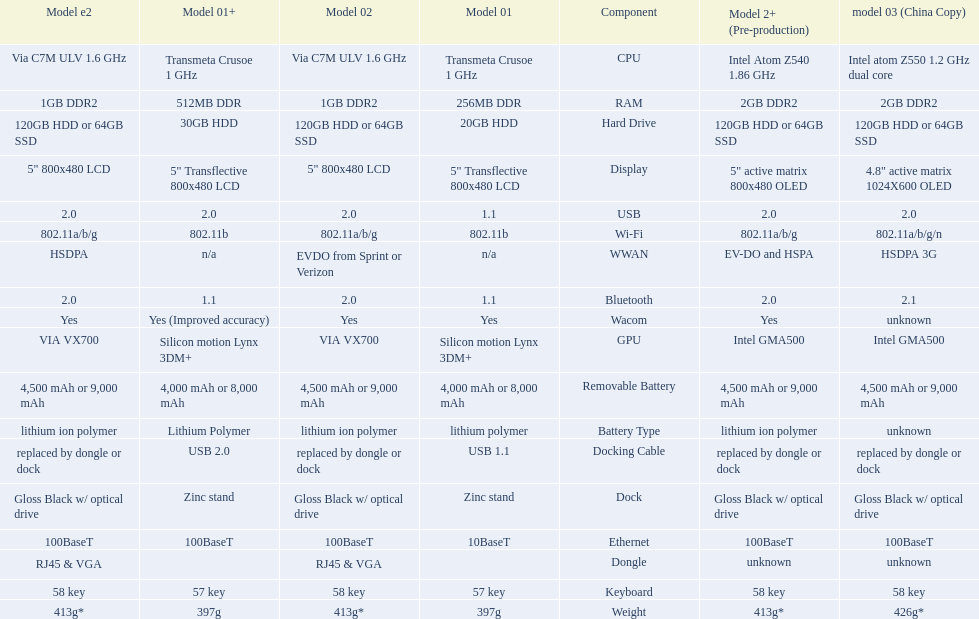Parse the full table. {'header': ['Model e2', 'Model 01+', 'Model 02', 'Model 01', 'Component', 'Model 2+ (Pre-production)', 'model 03 (China Copy)'], 'rows': [['Via C7M ULV 1.6\xa0GHz', 'Transmeta Crusoe 1\xa0GHz', 'Via C7M ULV 1.6\xa0GHz', 'Transmeta Crusoe 1\xa0GHz', 'CPU', 'Intel Atom Z540 1.86\xa0GHz', 'Intel atom Z550 1.2\xa0GHz dual core'], ['1GB DDR2', '512MB DDR', '1GB DDR2', '256MB DDR', 'RAM', '2GB DDR2', '2GB DDR2'], ['120GB HDD or 64GB SSD', '30GB HDD', '120GB HDD or 64GB SSD', '20GB HDD', 'Hard Drive', '120GB HDD or 64GB SSD', '120GB HDD or 64GB SSD'], ['5" 800x480 LCD', '5" Transflective 800x480 LCD', '5" 800x480 LCD', '5" Transflective 800x480 LCD', 'Display', '5" active matrix 800x480 OLED', '4.8" active matrix 1024X600 OLED'], ['2.0', '2.0', '2.0', '1.1', 'USB', '2.0', '2.0'], ['802.11a/b/g', '802.11b', '802.11a/b/g', '802.11b', 'Wi-Fi', '802.11a/b/g', '802.11a/b/g/n'], ['HSDPA', 'n/a', 'EVDO from Sprint or Verizon', 'n/a', 'WWAN', 'EV-DO and HSPA', 'HSDPA 3G'], ['2.0', '1.1', '2.0', '1.1', 'Bluetooth', '2.0', '2.1'], ['Yes', 'Yes (Improved accuracy)', 'Yes', 'Yes', 'Wacom', 'Yes', 'unknown'], ['VIA VX700', 'Silicon motion Lynx 3DM+', 'VIA VX700', 'Silicon motion Lynx 3DM+', 'GPU', 'Intel GMA500', 'Intel GMA500'], ['4,500 mAh or 9,000 mAh', '4,000 mAh or 8,000 mAh', '4,500 mAh or 9,000 mAh', '4,000 mAh or 8,000 mAh', 'Removable Battery', '4,500 mAh or 9,000 mAh', '4,500 mAh or 9,000 mAh'], ['lithium ion polymer', 'Lithium Polymer', 'lithium ion polymer', 'lithium polymer', 'Battery Type', 'lithium ion polymer', 'unknown'], ['replaced by dongle or dock', 'USB 2.0', 'replaced by dongle or dock', 'USB 1.1', 'Docking Cable', 'replaced by dongle or dock', 'replaced by dongle or dock'], ['Gloss Black w/ optical drive', 'Zinc stand', 'Gloss Black w/ optical drive', 'Zinc stand', 'Dock', 'Gloss Black w/ optical drive', 'Gloss Black w/ optical drive'], ['100BaseT', '100BaseT', '100BaseT', '10BaseT', 'Ethernet', '100BaseT', '100BaseT'], ['RJ45 & VGA', '', 'RJ45 & VGA', '', 'Dongle', 'unknown', 'unknown'], ['58 key', '57 key', '58 key', '57 key', 'Keyboard', '58 key', '58 key'], ['413g*', '397g', '413g*', '397g', 'Weight', '413g*', '426g*']]} How many models have 1.6ghz? 2. 